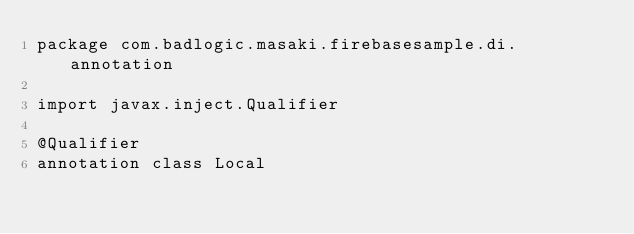<code> <loc_0><loc_0><loc_500><loc_500><_Kotlin_>package com.badlogic.masaki.firebasesample.di.annotation

import javax.inject.Qualifier

@Qualifier
annotation class Local
</code> 